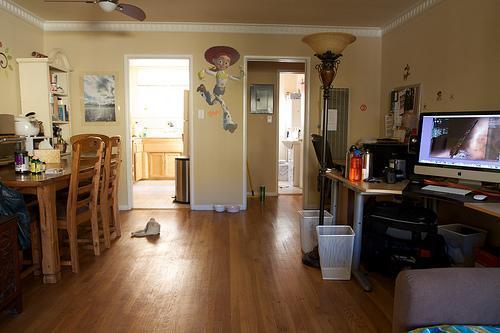How many computers are there?
Give a very brief answer. 1. 